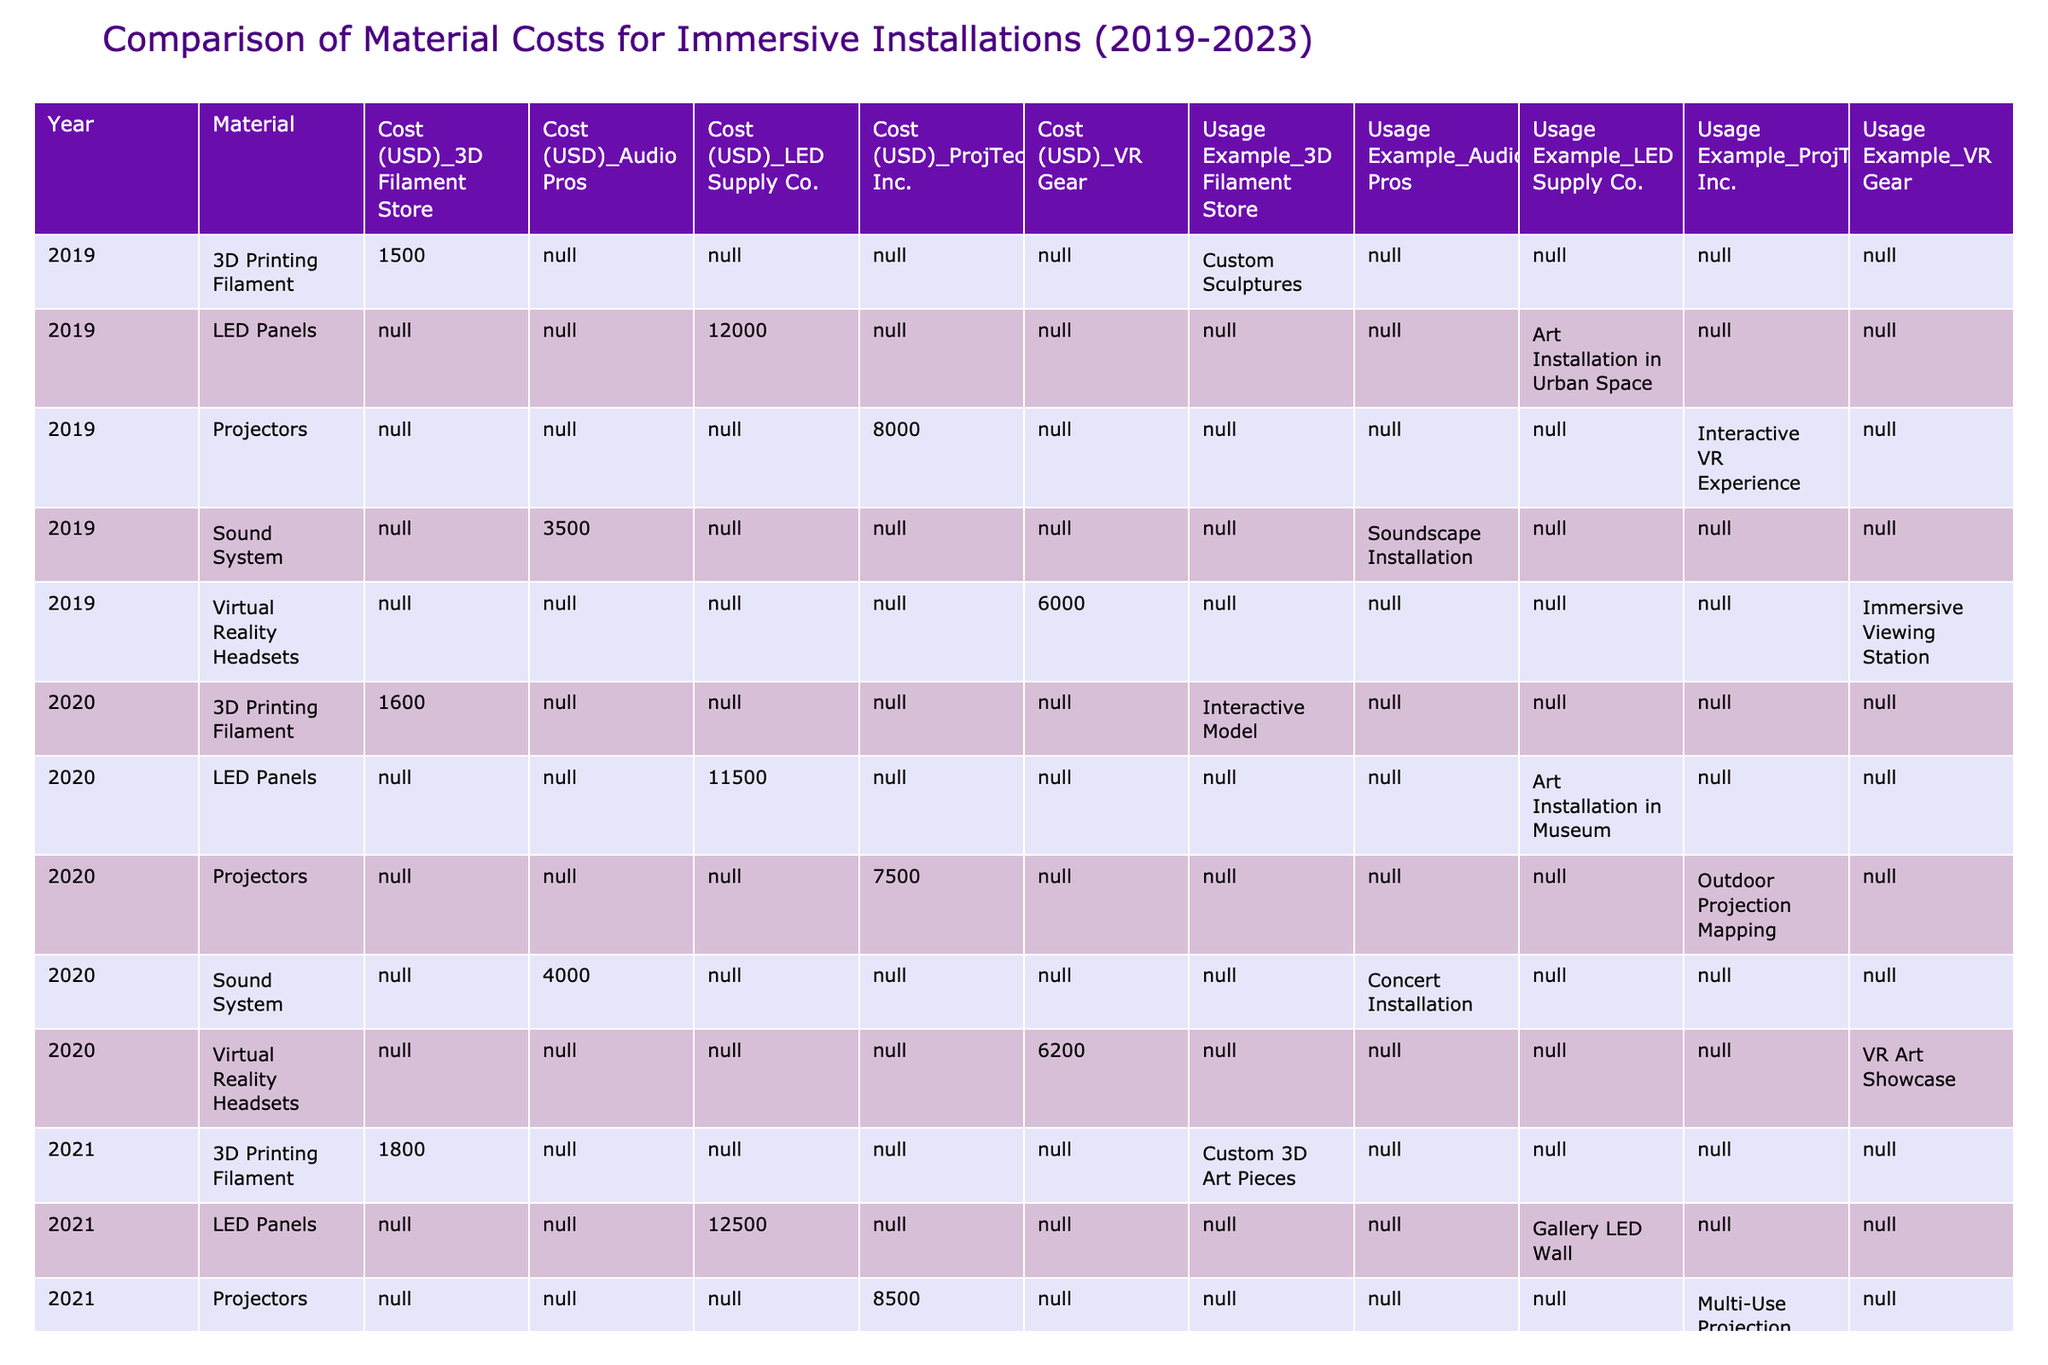What is the cost of LED Panels in 2021? In the table, under the year 2021, the cost for LED Panels is listed as 12,500 USD.
Answer: 12,500 USD Which material had the highest cost in 2022? In 2022, LED Panels cost 13,000 USD, which is higher than any other material listed for that year.
Answer: LED Panels How much did the cost of 3D Printing Filament increase from 2019 to 2023? The cost of 3D Printing Filament in 2019 was 1,500 USD, and in 2023 it is 1,750 USD. The increase is 1,750 - 1,500 = 250 USD.
Answer: 250 USD Did the cost of Virtual Reality Headsets increase every year from 2019 to 2023? Looking at the data, the prices of Virtual Reality Headsets are: 6,000 (2019), 6,200 (2020), 6,400 (2021), 6,500 (2022), and 6,600 (2023). Each year shows an increase, confirming the statement is true.
Answer: Yes What is the average cost of Projectors from 2019 to 2023? The costs of Projectors are: 8,000 (2019), 7,500 (2020), 8,500 (2021), 9,000 (2022), and 9,200 (2023). Summing these gives 8,000 + 7,500 + 8,500 + 9,000 + 9,200 = 42,200 USD. There are 5 data points, so the average is 42,200 / 5 = 8,440 USD.
Answer: 8,440 USD What was the cheapest material in 2021? In the year 2021, the costs are: LED Panels 12,500 USD, Projectors 8,500 USD, Sound System 3,700 USD, 3D Printing Filament 1,800 USD, and Virtual Reality Headsets 6,400 USD. The lowest cost is for 3D Printing Filament at 1,800 USD.
Answer: 3D Printing Filament Which supplier provided the cheapest Sound System in 2020? From the table, the cost of the Sound System from Audio Pros in 2020 was 4,000 USD. This appears to be the only supplier for the Sound System in that year, making it the cheapest option listed.
Answer: Audio Pros How much more expensive were LED Panels in 2022 compared to 2020? The cost of LED Panels in 2020 is 11,500 USD, and in 2022 it is 13,000 USD. The difference is 13,000 - 11,500 = 1,500 USD.
Answer: 1,500 USD Was there a decrease in cost for Sound Systems from 2019 to 2022? Checking the costs for the Sound System: 3,500 (2019), 4,000 (2020), 3,700 (2021), and 3,900 (2022). The first value is less than the following years, confirming there was no consistent decrease.
Answer: No Which material had the largest price increase from 2019 to 2023? The costs for each material from 2019 to 2023 are: LED Panels (12,000 to 12,800) = +800 USD, Projectors (8,000 to 9,200) = +1,200 USD, Sound System (3,500 to 4,100) = +600 USD, 3D Printing Filament (1,500 to 1,750) = +250 USD, and Virtual Reality Headsets (6,000 to 6,600) = +600 USD. The largest increase is for Projectors at 1,200 USD.
Answer: Projectors 